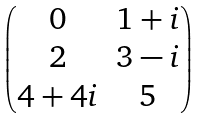Convert formula to latex. <formula><loc_0><loc_0><loc_500><loc_500>\begin{pmatrix} 0 & 1 + i \\ 2 & 3 - i \\ 4 + 4 i & 5 \end{pmatrix}</formula> 